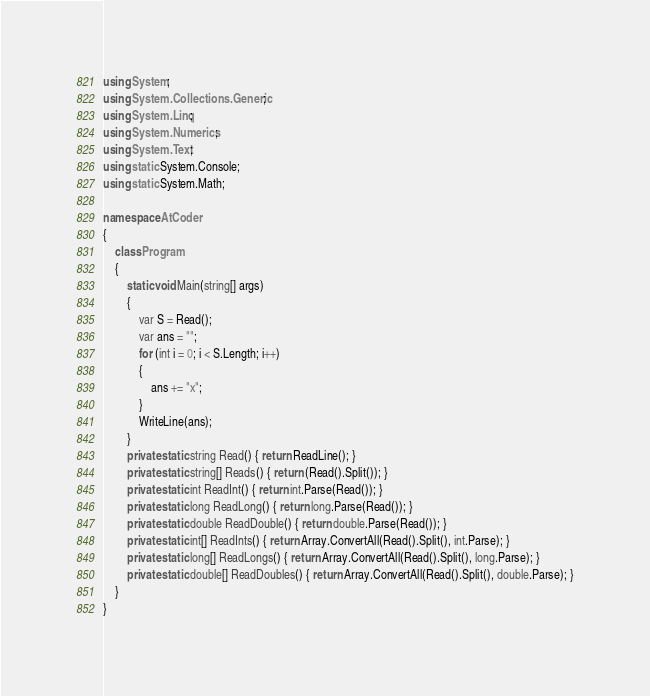<code> <loc_0><loc_0><loc_500><loc_500><_C#_>using System;
using System.Collections.Generic;
using System.Linq;
using System.Numerics;
using System.Text;
using static System.Console;
using static System.Math;

namespace AtCoder
{
    class Program
    {
        static void Main(string[] args)
        {
            var S = Read();
            var ans = "";
            for (int i = 0; i < S.Length; i++)
            {
                ans += "x";
            }
            WriteLine(ans);
        }
        private static string Read() { return ReadLine(); }
        private static string[] Reads() { return (Read().Split()); }
        private static int ReadInt() { return int.Parse(Read()); }
        private static long ReadLong() { return long.Parse(Read()); }
        private static double ReadDouble() { return double.Parse(Read()); }
        private static int[] ReadInts() { return Array.ConvertAll(Read().Split(), int.Parse); }
        private static long[] ReadLongs() { return Array.ConvertAll(Read().Split(), long.Parse); }
        private static double[] ReadDoubles() { return Array.ConvertAll(Read().Split(), double.Parse); }
    }
}
</code> 